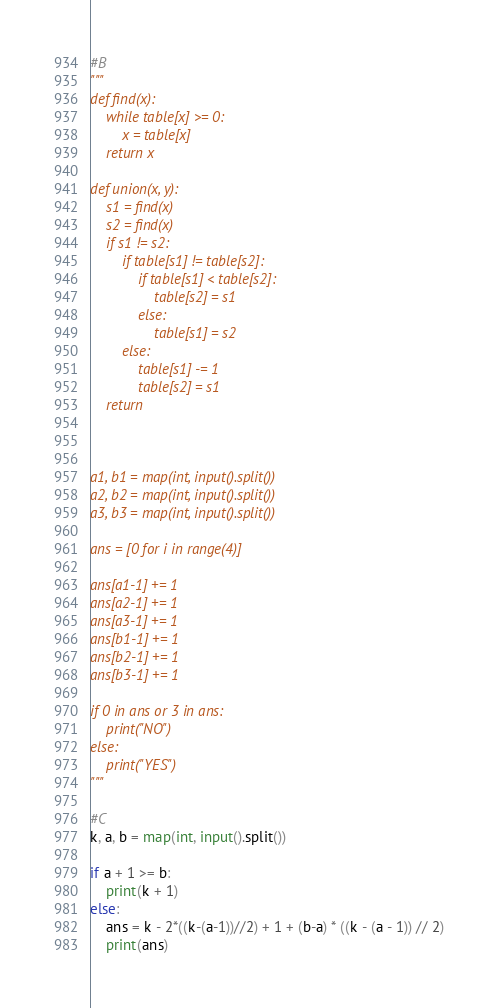Convert code to text. <code><loc_0><loc_0><loc_500><loc_500><_Python_>#B
"""
def find(x):
    while table[x] >= 0:
        x = table[x]
    return x

def union(x, y):
    s1 = find(x)
    s2 = find(x)
    if s1 != s2:
        if table[s1] != table[s2]:
            if table[s1] < table[s2]:
                table[s2] = s1
            else:
                table[s1] = s2
        else:
            table[s1] -= 1
            table[s2] = s1
    return
    


a1, b1 = map(int, input().split())
a2, b2 = map(int, input().split())
a3, b3 = map(int, input().split())

ans = [0 for i in range(4)]

ans[a1-1] += 1 
ans[a2-1] += 1 
ans[a3-1] += 1 
ans[b1-1] += 1 
ans[b2-1] += 1 
ans[b3-1] += 1 

if 0 in ans or 3 in ans:
    print("NO")
else:
    print("YES")
"""

#C
k, a, b = map(int, input().split())

if a + 1 >= b:
    print(k + 1)
else:
    ans = k - 2*((k-(a-1))//2) + 1 + (b-a) * ((k - (a - 1)) // 2)
    print(ans)</code> 